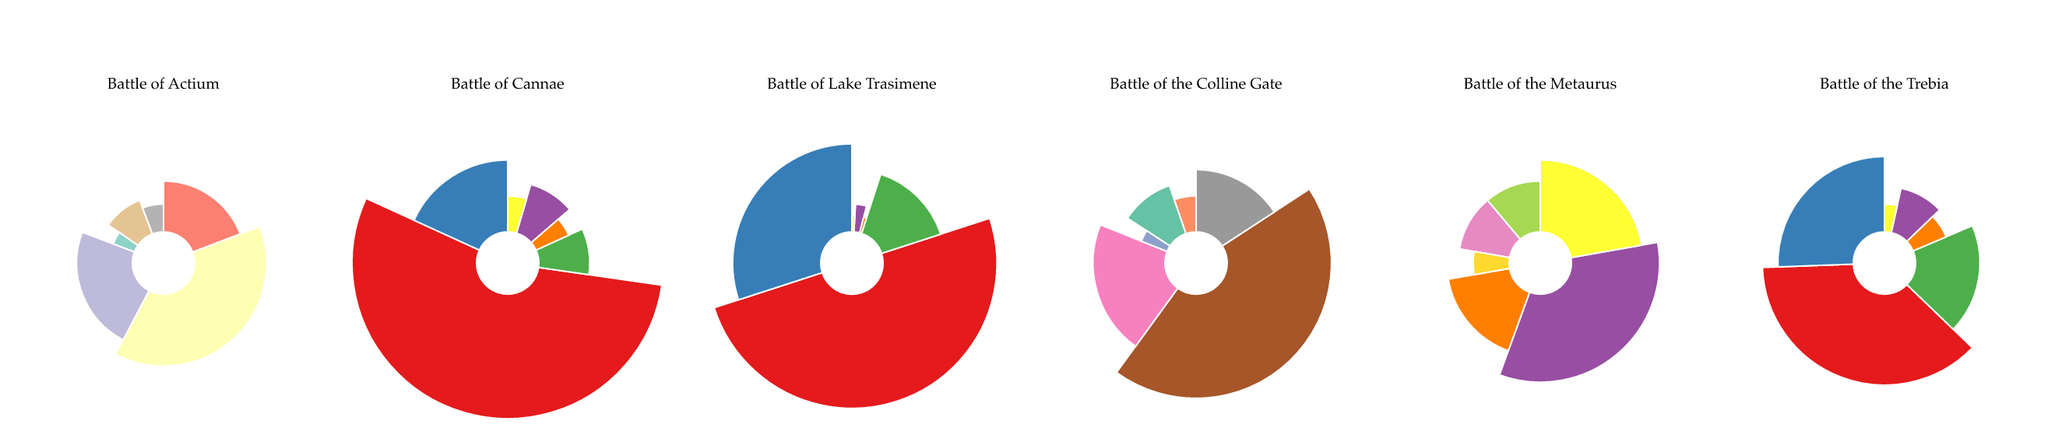What's the percentage of Romans killed in the Battle of Cannae? The plot for the Battle of Cannae shows a segment with the label "Romans Killed" and its corresponding percentage. Refer to this value in the chart.
Answer: 60% Which battle had the highest percentage of wounded forces for the Carthaginians? Examine each subplot's segments labeled "Carthaginians Wounded" and compare their percentages across the battles. The highest percentage is in the Battle of the Metaurus.
Answer: Battle of the Metaurus Sum the percentage of Romans captured in all battles. Add the percentage values for "Romans Captured" in the Battle of Cannae, the Battle of Lake Trasimene, and the Battle of the Trebia. The sum is 10 + 15 + 16 = 41%.
Answer: 41% Which side had more casualties (killed, wounded, and captured) in the Battle of Actium? Calculate the sum of killed, wounded, and captured percentages for both Augustan and Antonians in the Battle of Actium. Augustan: 5 + 3 + 2 = 10%. Antonians: 20 + 12 + 10 = 42%. Thus, Antonians had more casualties.
Answer: Antonians In which battles did the Romans suffer a higher percentage of killed compared to their wounded? Compare the segments labeled "Romans Killed" and "Romans Wounded" in each battle fought by Romans. The battles fulfilling this condition are the Battle of Cannae (60% vs 20%) and the Battle of the Trebia (32% vs 22%).
Answer: Battle of Cannae and Battle of the Trebia What's the total percentage of forces killed in the Battle of Lake Trasimene? Add the percentage values for "Romans Killed" and "Carthaginians Killed" in the Battle of Lake Trasimene. The total is 50% (Romans) + 3% (Carthaginians) = 53%.
Answer: 53% How does the percentage of wounded forces compare between the Marians and Sullans in the Battle of the Colline Gate? Look at the segments for "Marians Wounded" and "Sullans Wounded" in the Battle of the Colline Gate. Marians have 20%, and Sullans have 5%. Marians have a higher percentage of wounded forces.
Answer: Marians have more wounded What’s the difference in captured forces between the Battle of the Metaurus and the Battle of Actium? Calculate the total percentage of captured forces for both battles. The Battle of the Metaurus: 20% (Carthaginians) + 5% (Roman) = 25%. The Battle of Actium: 2% (Augustan) + 10% (Antonians) = 12%. The difference is 25% - 12% = 13%.
Answer: 13% Which battle has the smallest percentage of wounded forces overall? Examine the segments for wounded forces (combining both sides) in each battle and identify the smallest total percentage. This occurs in the Battle of Actium: 3% (Augustan) + 12% (Antonians) = 15%.
Answer: Battle of Actium 